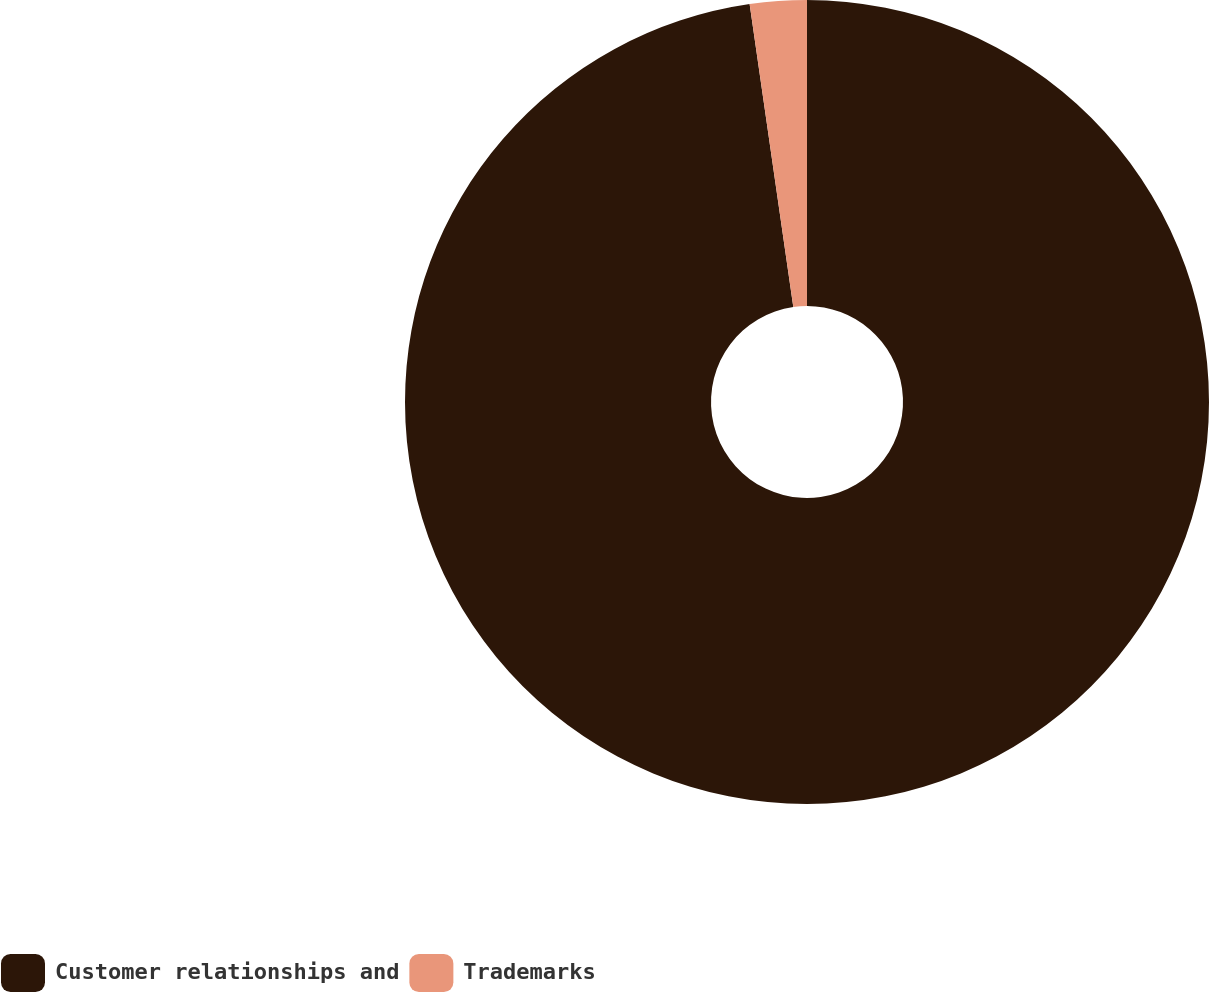Convert chart. <chart><loc_0><loc_0><loc_500><loc_500><pie_chart><fcel>Customer relationships and<fcel>Trademarks<nl><fcel>97.72%<fcel>2.28%<nl></chart> 